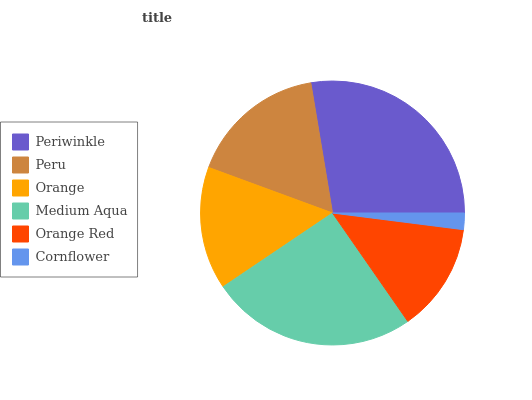Is Cornflower the minimum?
Answer yes or no. Yes. Is Periwinkle the maximum?
Answer yes or no. Yes. Is Peru the minimum?
Answer yes or no. No. Is Peru the maximum?
Answer yes or no. No. Is Periwinkle greater than Peru?
Answer yes or no. Yes. Is Peru less than Periwinkle?
Answer yes or no. Yes. Is Peru greater than Periwinkle?
Answer yes or no. No. Is Periwinkle less than Peru?
Answer yes or no. No. Is Peru the high median?
Answer yes or no. Yes. Is Orange the low median?
Answer yes or no. Yes. Is Orange Red the high median?
Answer yes or no. No. Is Cornflower the low median?
Answer yes or no. No. 